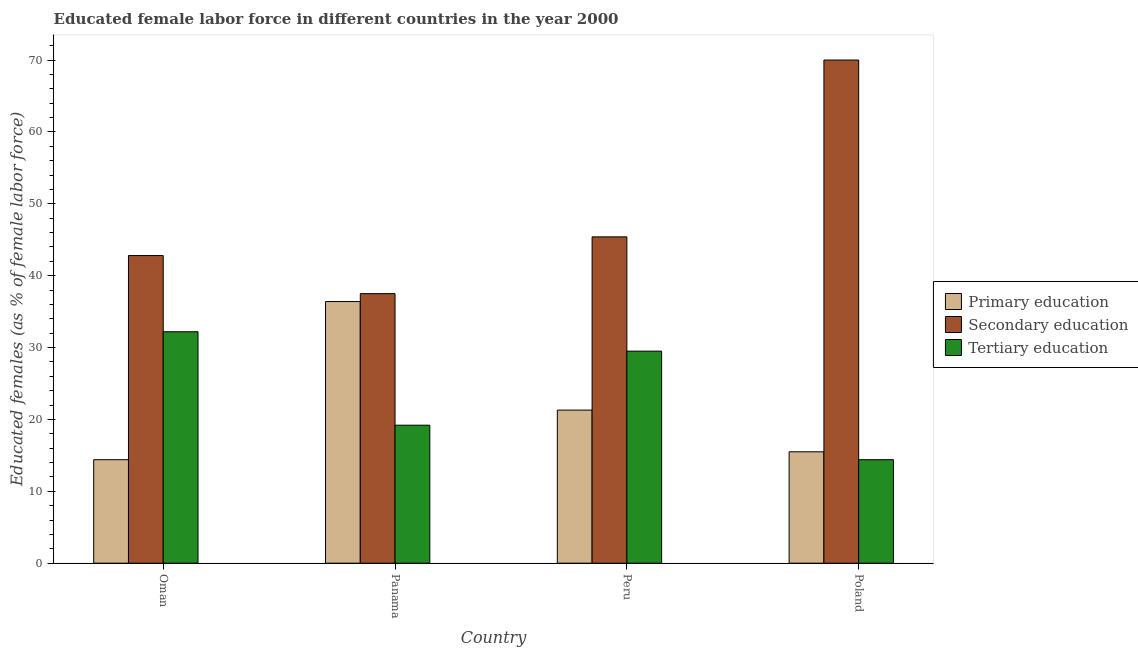How many groups of bars are there?
Your answer should be very brief. 4. What is the label of the 3rd group of bars from the left?
Ensure brevity in your answer.  Peru. What is the percentage of female labor force who received tertiary education in Poland?
Keep it short and to the point. 14.4. Across all countries, what is the minimum percentage of female labor force who received tertiary education?
Provide a short and direct response. 14.4. In which country was the percentage of female labor force who received primary education minimum?
Your response must be concise. Oman. What is the total percentage of female labor force who received primary education in the graph?
Your answer should be very brief. 87.6. What is the difference between the percentage of female labor force who received primary education in Peru and that in Poland?
Your answer should be very brief. 5.8. What is the difference between the percentage of female labor force who received secondary education in Poland and the percentage of female labor force who received tertiary education in Oman?
Your answer should be very brief. 37.8. What is the average percentage of female labor force who received primary education per country?
Your response must be concise. 21.9. What is the difference between the percentage of female labor force who received tertiary education and percentage of female labor force who received secondary education in Poland?
Offer a very short reply. -55.6. In how many countries, is the percentage of female labor force who received tertiary education greater than 24 %?
Your answer should be compact. 2. What is the ratio of the percentage of female labor force who received tertiary education in Oman to that in Peru?
Provide a short and direct response. 1.09. Is the percentage of female labor force who received primary education in Oman less than that in Poland?
Your answer should be very brief. Yes. Is the difference between the percentage of female labor force who received secondary education in Oman and Panama greater than the difference between the percentage of female labor force who received tertiary education in Oman and Panama?
Offer a very short reply. No. What is the difference between the highest and the second highest percentage of female labor force who received tertiary education?
Provide a short and direct response. 2.7. What is the difference between the highest and the lowest percentage of female labor force who received primary education?
Your answer should be very brief. 22. In how many countries, is the percentage of female labor force who received primary education greater than the average percentage of female labor force who received primary education taken over all countries?
Your response must be concise. 1. What does the 1st bar from the left in Peru represents?
Make the answer very short. Primary education. What does the 2nd bar from the right in Poland represents?
Provide a short and direct response. Secondary education. How many bars are there?
Offer a terse response. 12. What is the difference between two consecutive major ticks on the Y-axis?
Ensure brevity in your answer.  10. Are the values on the major ticks of Y-axis written in scientific E-notation?
Your answer should be compact. No. Does the graph contain any zero values?
Provide a succinct answer. No. How are the legend labels stacked?
Offer a terse response. Vertical. What is the title of the graph?
Give a very brief answer. Educated female labor force in different countries in the year 2000. Does "Tertiary" appear as one of the legend labels in the graph?
Keep it short and to the point. No. What is the label or title of the X-axis?
Offer a very short reply. Country. What is the label or title of the Y-axis?
Give a very brief answer. Educated females (as % of female labor force). What is the Educated females (as % of female labor force) in Primary education in Oman?
Offer a very short reply. 14.4. What is the Educated females (as % of female labor force) in Secondary education in Oman?
Keep it short and to the point. 42.8. What is the Educated females (as % of female labor force) of Tertiary education in Oman?
Make the answer very short. 32.2. What is the Educated females (as % of female labor force) in Primary education in Panama?
Keep it short and to the point. 36.4. What is the Educated females (as % of female labor force) in Secondary education in Panama?
Ensure brevity in your answer.  37.5. What is the Educated females (as % of female labor force) of Tertiary education in Panama?
Your answer should be very brief. 19.2. What is the Educated females (as % of female labor force) of Primary education in Peru?
Offer a very short reply. 21.3. What is the Educated females (as % of female labor force) in Secondary education in Peru?
Your response must be concise. 45.4. What is the Educated females (as % of female labor force) in Tertiary education in Peru?
Provide a short and direct response. 29.5. What is the Educated females (as % of female labor force) in Primary education in Poland?
Ensure brevity in your answer.  15.5. What is the Educated females (as % of female labor force) in Secondary education in Poland?
Give a very brief answer. 70. What is the Educated females (as % of female labor force) in Tertiary education in Poland?
Your response must be concise. 14.4. Across all countries, what is the maximum Educated females (as % of female labor force) of Primary education?
Your answer should be compact. 36.4. Across all countries, what is the maximum Educated females (as % of female labor force) of Tertiary education?
Keep it short and to the point. 32.2. Across all countries, what is the minimum Educated females (as % of female labor force) of Primary education?
Provide a succinct answer. 14.4. Across all countries, what is the minimum Educated females (as % of female labor force) in Secondary education?
Your answer should be compact. 37.5. Across all countries, what is the minimum Educated females (as % of female labor force) of Tertiary education?
Provide a succinct answer. 14.4. What is the total Educated females (as % of female labor force) of Primary education in the graph?
Your response must be concise. 87.6. What is the total Educated females (as % of female labor force) of Secondary education in the graph?
Make the answer very short. 195.7. What is the total Educated females (as % of female labor force) of Tertiary education in the graph?
Your response must be concise. 95.3. What is the difference between the Educated females (as % of female labor force) in Secondary education in Oman and that in Panama?
Your answer should be compact. 5.3. What is the difference between the Educated females (as % of female labor force) in Tertiary education in Oman and that in Panama?
Provide a short and direct response. 13. What is the difference between the Educated females (as % of female labor force) in Secondary education in Oman and that in Poland?
Provide a succinct answer. -27.2. What is the difference between the Educated females (as % of female labor force) in Primary education in Panama and that in Poland?
Your response must be concise. 20.9. What is the difference between the Educated females (as % of female labor force) in Secondary education in Panama and that in Poland?
Offer a very short reply. -32.5. What is the difference between the Educated females (as % of female labor force) of Tertiary education in Panama and that in Poland?
Provide a short and direct response. 4.8. What is the difference between the Educated females (as % of female labor force) of Primary education in Peru and that in Poland?
Your answer should be compact. 5.8. What is the difference between the Educated females (as % of female labor force) in Secondary education in Peru and that in Poland?
Keep it short and to the point. -24.6. What is the difference between the Educated females (as % of female labor force) in Primary education in Oman and the Educated females (as % of female labor force) in Secondary education in Panama?
Your answer should be very brief. -23.1. What is the difference between the Educated females (as % of female labor force) of Secondary education in Oman and the Educated females (as % of female labor force) of Tertiary education in Panama?
Offer a very short reply. 23.6. What is the difference between the Educated females (as % of female labor force) of Primary education in Oman and the Educated females (as % of female labor force) of Secondary education in Peru?
Your response must be concise. -31. What is the difference between the Educated females (as % of female labor force) of Primary education in Oman and the Educated females (as % of female labor force) of Tertiary education in Peru?
Keep it short and to the point. -15.1. What is the difference between the Educated females (as % of female labor force) in Primary education in Oman and the Educated females (as % of female labor force) in Secondary education in Poland?
Your response must be concise. -55.6. What is the difference between the Educated females (as % of female labor force) in Secondary education in Oman and the Educated females (as % of female labor force) in Tertiary education in Poland?
Provide a succinct answer. 28.4. What is the difference between the Educated females (as % of female labor force) of Primary education in Panama and the Educated females (as % of female labor force) of Secondary education in Peru?
Offer a very short reply. -9. What is the difference between the Educated females (as % of female labor force) of Primary education in Panama and the Educated females (as % of female labor force) of Tertiary education in Peru?
Ensure brevity in your answer.  6.9. What is the difference between the Educated females (as % of female labor force) of Primary education in Panama and the Educated females (as % of female labor force) of Secondary education in Poland?
Offer a terse response. -33.6. What is the difference between the Educated females (as % of female labor force) of Secondary education in Panama and the Educated females (as % of female labor force) of Tertiary education in Poland?
Give a very brief answer. 23.1. What is the difference between the Educated females (as % of female labor force) of Primary education in Peru and the Educated females (as % of female labor force) of Secondary education in Poland?
Your answer should be very brief. -48.7. What is the difference between the Educated females (as % of female labor force) of Secondary education in Peru and the Educated females (as % of female labor force) of Tertiary education in Poland?
Ensure brevity in your answer.  31. What is the average Educated females (as % of female labor force) of Primary education per country?
Offer a terse response. 21.9. What is the average Educated females (as % of female labor force) in Secondary education per country?
Your answer should be compact. 48.92. What is the average Educated females (as % of female labor force) of Tertiary education per country?
Your response must be concise. 23.82. What is the difference between the Educated females (as % of female labor force) of Primary education and Educated females (as % of female labor force) of Secondary education in Oman?
Provide a short and direct response. -28.4. What is the difference between the Educated females (as % of female labor force) of Primary education and Educated females (as % of female labor force) of Tertiary education in Oman?
Your response must be concise. -17.8. What is the difference between the Educated females (as % of female labor force) of Secondary education and Educated females (as % of female labor force) of Tertiary education in Oman?
Your answer should be compact. 10.6. What is the difference between the Educated females (as % of female labor force) in Primary education and Educated females (as % of female labor force) in Secondary education in Panama?
Your answer should be very brief. -1.1. What is the difference between the Educated females (as % of female labor force) in Primary education and Educated females (as % of female labor force) in Secondary education in Peru?
Provide a succinct answer. -24.1. What is the difference between the Educated females (as % of female labor force) in Primary education and Educated females (as % of female labor force) in Tertiary education in Peru?
Your answer should be very brief. -8.2. What is the difference between the Educated females (as % of female labor force) of Secondary education and Educated females (as % of female labor force) of Tertiary education in Peru?
Keep it short and to the point. 15.9. What is the difference between the Educated females (as % of female labor force) of Primary education and Educated females (as % of female labor force) of Secondary education in Poland?
Your answer should be very brief. -54.5. What is the difference between the Educated females (as % of female labor force) in Primary education and Educated females (as % of female labor force) in Tertiary education in Poland?
Give a very brief answer. 1.1. What is the difference between the Educated females (as % of female labor force) of Secondary education and Educated females (as % of female labor force) of Tertiary education in Poland?
Ensure brevity in your answer.  55.6. What is the ratio of the Educated females (as % of female labor force) in Primary education in Oman to that in Panama?
Offer a terse response. 0.4. What is the ratio of the Educated females (as % of female labor force) of Secondary education in Oman to that in Panama?
Provide a succinct answer. 1.14. What is the ratio of the Educated females (as % of female labor force) of Tertiary education in Oman to that in Panama?
Give a very brief answer. 1.68. What is the ratio of the Educated females (as % of female labor force) of Primary education in Oman to that in Peru?
Your response must be concise. 0.68. What is the ratio of the Educated females (as % of female labor force) of Secondary education in Oman to that in Peru?
Your response must be concise. 0.94. What is the ratio of the Educated females (as % of female labor force) of Tertiary education in Oman to that in Peru?
Provide a succinct answer. 1.09. What is the ratio of the Educated females (as % of female labor force) in Primary education in Oman to that in Poland?
Ensure brevity in your answer.  0.93. What is the ratio of the Educated females (as % of female labor force) in Secondary education in Oman to that in Poland?
Offer a very short reply. 0.61. What is the ratio of the Educated females (as % of female labor force) of Tertiary education in Oman to that in Poland?
Your answer should be compact. 2.24. What is the ratio of the Educated females (as % of female labor force) in Primary education in Panama to that in Peru?
Your answer should be very brief. 1.71. What is the ratio of the Educated females (as % of female labor force) of Secondary education in Panama to that in Peru?
Your answer should be compact. 0.83. What is the ratio of the Educated females (as % of female labor force) in Tertiary education in Panama to that in Peru?
Your answer should be very brief. 0.65. What is the ratio of the Educated females (as % of female labor force) of Primary education in Panama to that in Poland?
Give a very brief answer. 2.35. What is the ratio of the Educated females (as % of female labor force) in Secondary education in Panama to that in Poland?
Make the answer very short. 0.54. What is the ratio of the Educated females (as % of female labor force) of Primary education in Peru to that in Poland?
Your answer should be compact. 1.37. What is the ratio of the Educated females (as % of female labor force) of Secondary education in Peru to that in Poland?
Your response must be concise. 0.65. What is the ratio of the Educated females (as % of female labor force) of Tertiary education in Peru to that in Poland?
Provide a short and direct response. 2.05. What is the difference between the highest and the second highest Educated females (as % of female labor force) of Primary education?
Provide a succinct answer. 15.1. What is the difference between the highest and the second highest Educated females (as % of female labor force) of Secondary education?
Keep it short and to the point. 24.6. What is the difference between the highest and the lowest Educated females (as % of female labor force) of Secondary education?
Your answer should be very brief. 32.5. 